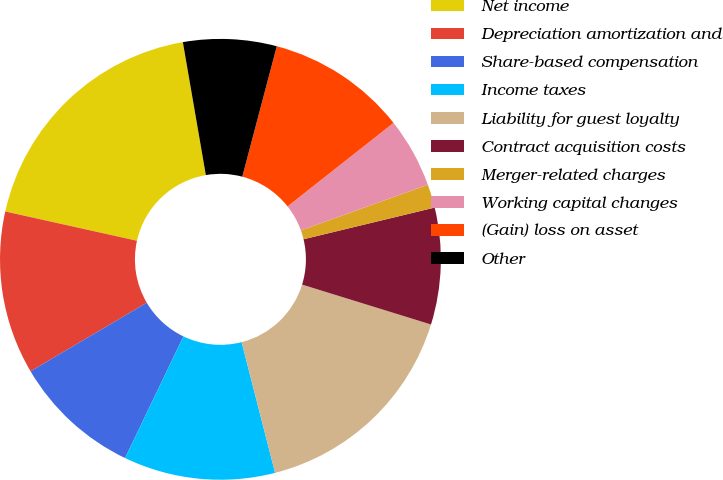<chart> <loc_0><loc_0><loc_500><loc_500><pie_chart><fcel>Net income<fcel>Depreciation amortization and<fcel>Share-based compensation<fcel>Income taxes<fcel>Liability for guest loyalty<fcel>Contract acquisition costs<fcel>Merger-related charges<fcel>Working capital changes<fcel>(Gain) loss on asset<fcel>Other<nl><fcel>18.79%<fcel>11.96%<fcel>9.4%<fcel>11.11%<fcel>16.23%<fcel>8.55%<fcel>1.72%<fcel>5.13%<fcel>10.26%<fcel>6.84%<nl></chart> 